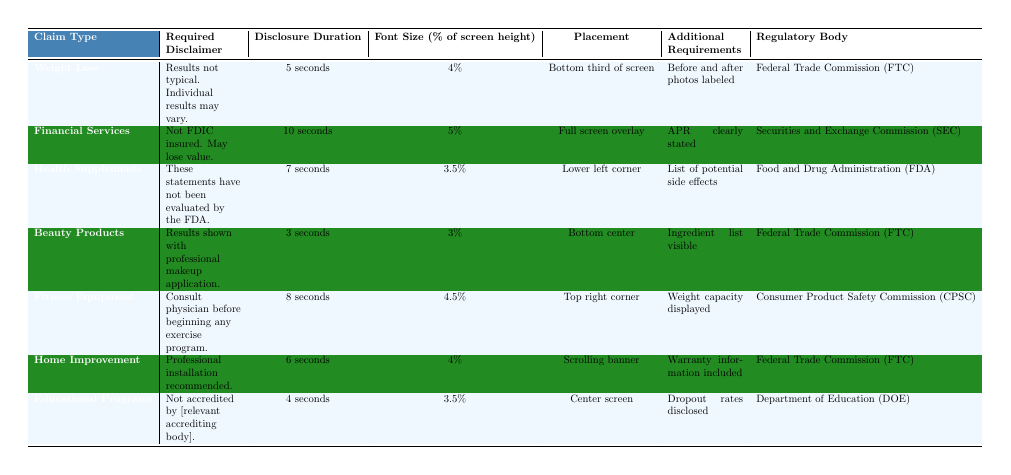What is the required disclaimer for Health Supplements? The table lists "These statements have not been evaluated by the FDA." under the Required Disclaimer column for Health Supplements.
Answer: These statements have not been evaluated by the FDA How long must the disclaimer for Financial Services be displayed? Looking at the Disclosure Duration column for Financial Services, it states "10 seconds."
Answer: 10 seconds What is the placement for disclaimers related to Fitness Equipment? The Placement column shows that disclaimers for Fitness Equipment should be in the "Top right corner."
Answer: Top right corner Which regulatory body oversees Home Improvement claims? The Regulatory Body column indicates that Home Improvement claims are overseen by the "Federal Trade Commission (FTC)."
Answer: Federal Trade Commission (FTC) How does the font size for the disclaimer in Beauty Products compare to that of Weight Loss? The Font Size for Beauty Products is "3%" and for Weight Loss is "4%." Comparing these values shows that Beauty Products has a smaller font size than Weight Loss.
Answer: It is smaller What is the average duration of disclaimers across all claim types? Summing the durations: 5 + 10 + 7 + 3 + 8 + 6 + 4 = 43 seconds. There are 7 claim types, so the average is 43 / 7 ≈ 6.14 seconds.
Answer: Approximately 6.14 seconds Are Home Improvement and Health Supplement claims both governed by the FTC? Checking the Regulatory Body for Home Improvement shows "Federal Trade Commission (FTC)" and for Health Supplements it shows "Food and Drug Administration (FDA)." Thus, they are governed by different regulatory bodies.
Answer: No What is the required disclaimer type with the shortest disclosure duration? The candidates are: Weight Loss (5 seconds), Health Supplements (7 seconds), Beauty Products (3 seconds), Fitness Equipment (8 seconds), Home Improvement (6 seconds), Educational Programs (4 seconds). The shortest is "3 seconds" for Beauty Products.
Answer: Beauty Products How many claim types require the additional requirement of a list of potential side effects? The Additional Requirements indicate that Health Supplements is the only type needing a list of potential side effects, so there is just 1.
Answer: 1 What are the differences in font size between Educational Programs and Beauty Products? The font size for Educational Programs is "3.5%" and for Beauty Products is "3%." The difference is 3.5% - 3% = 0.5%.
Answer: 0.5% Does every claim type have both a required disclaimer and a disclosure duration? Reviewing the table shows that every claim type has entries in both the Required Disclaimer and Disclosure Duration columns, confirming that they all have both elements.
Answer: Yes 